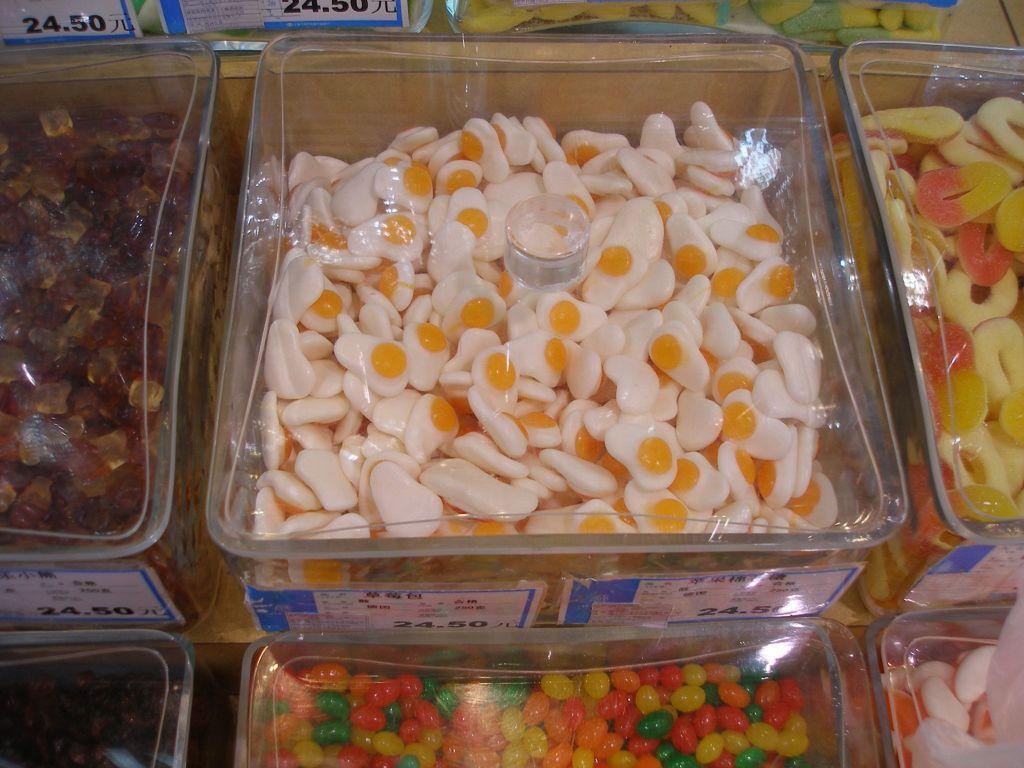Please provide a concise description of this image. In this image there are some glass boxes, and in the boxes there are some candies and some boards. On the boards there is text. 